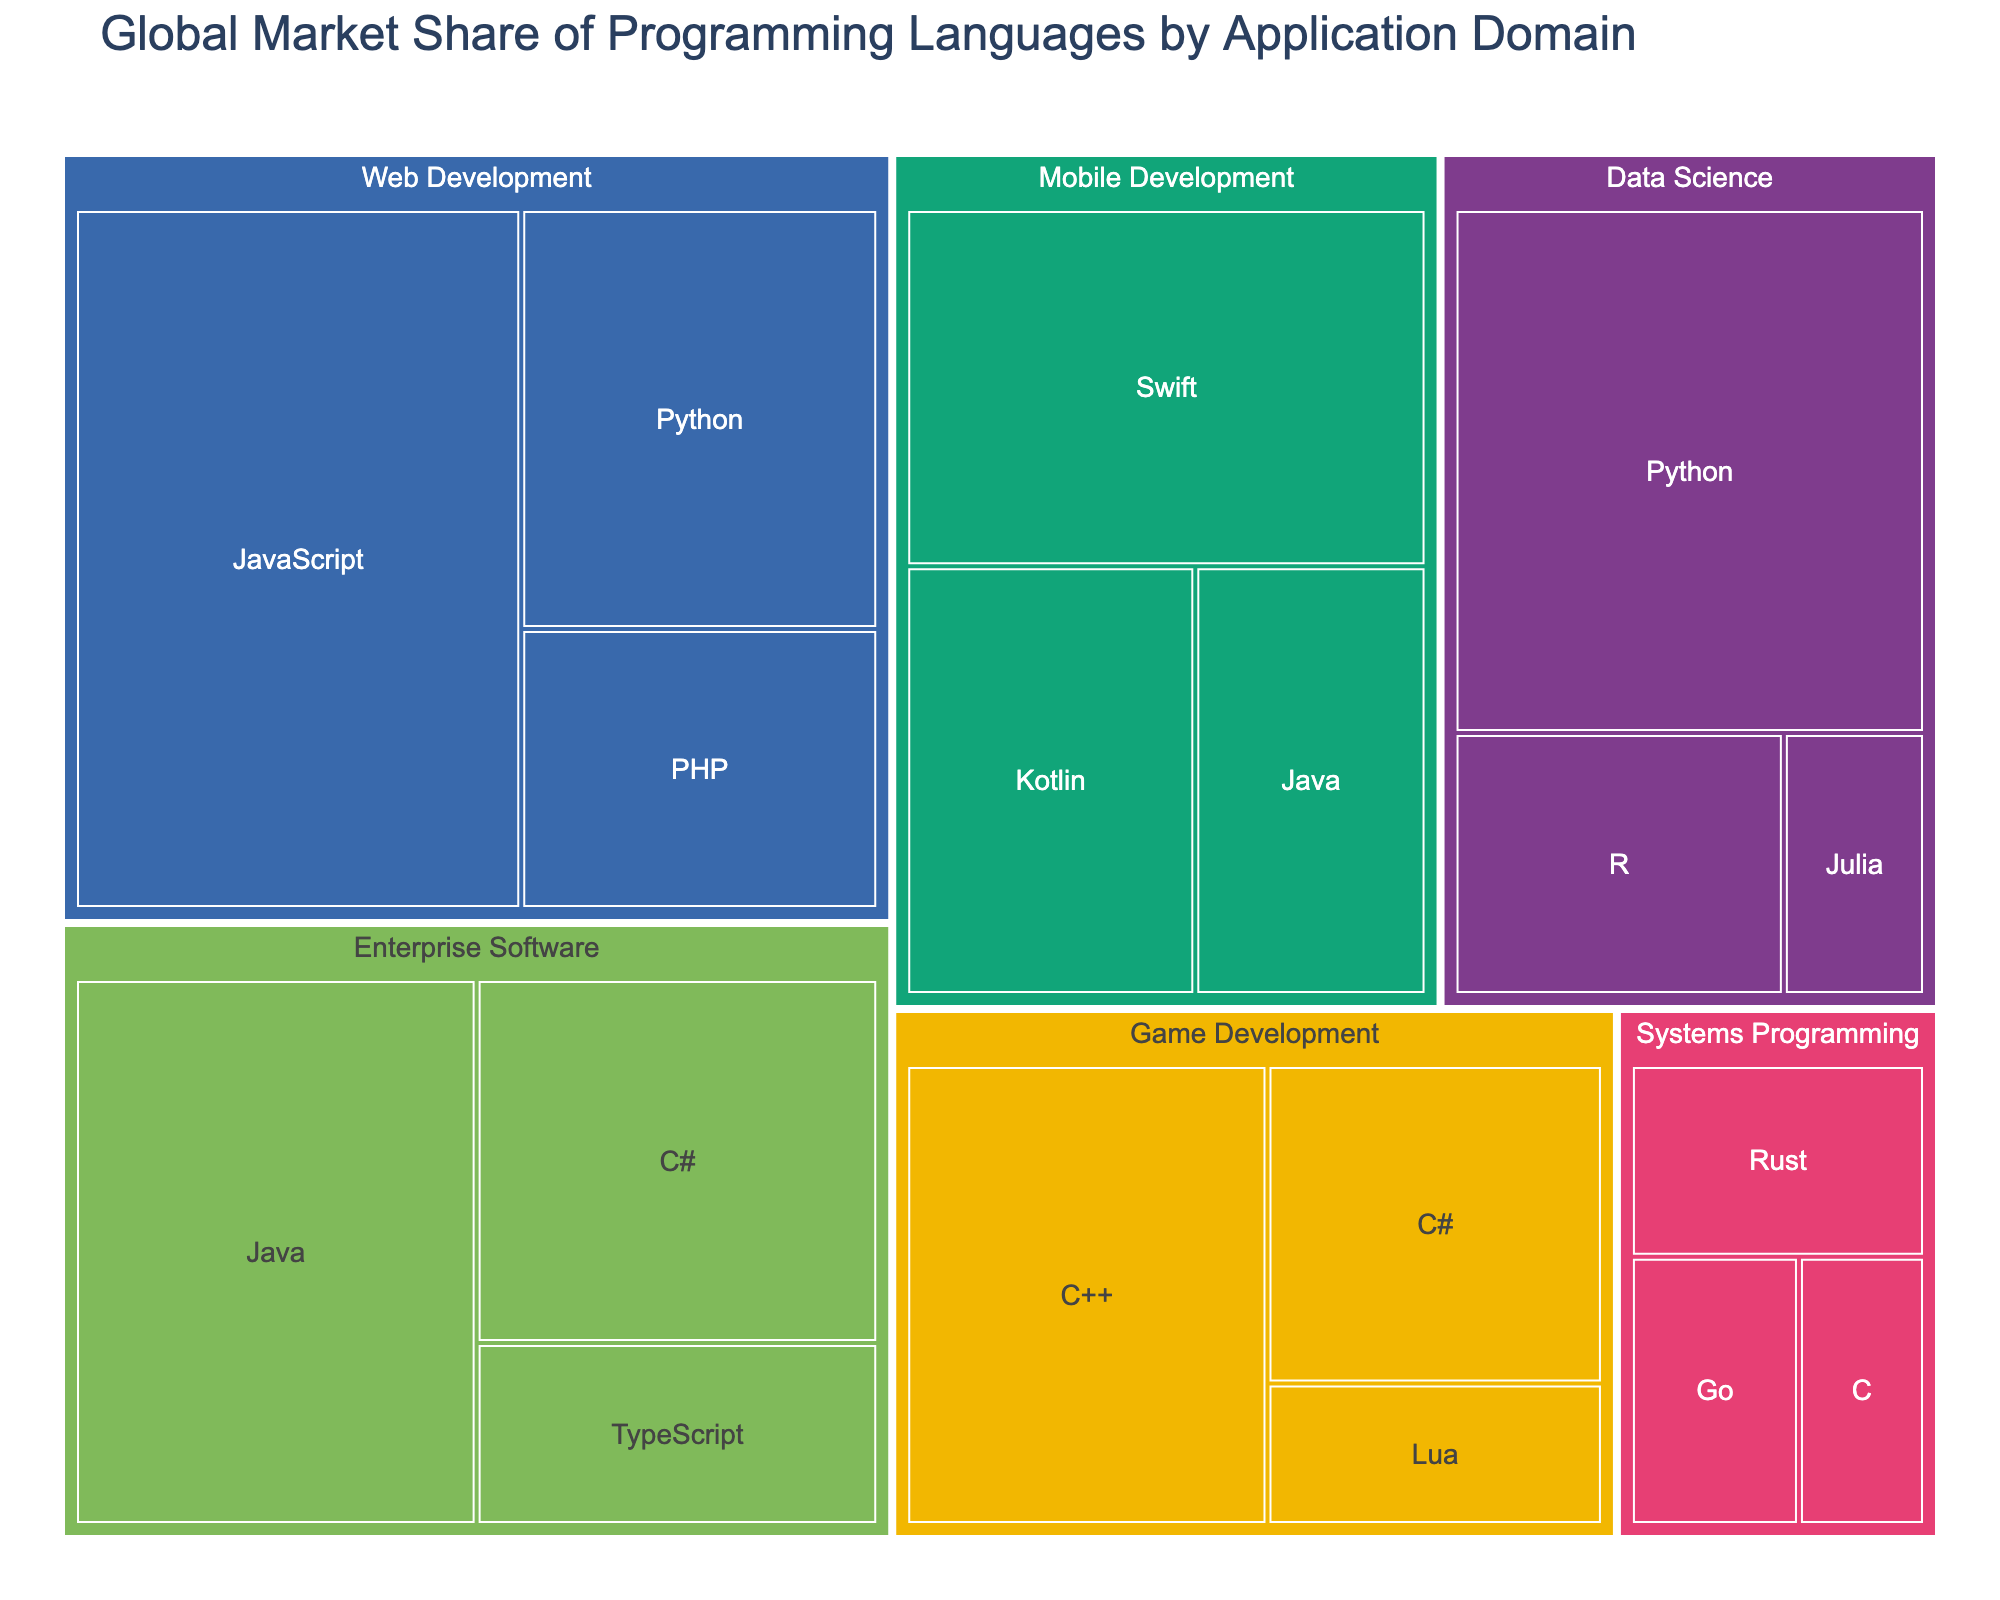1. What is the largest application domain in terms of global market share? Look at the treemap and identify which application domain has the largest area. Web Development has the largest area and thus the largest market share.
Answer: Web Development 2. Which programming language has the highest market share in data science? Find the Data Science application domain in the treemap and identify which programming language within it has the largest area. Python is the largest within Data Science.
Answer: Python 3. How does the market share of Java in enterprise software compare to the market share of Python in data science? Locate Java under Enterprise Software and Python under Data Science in the treemap, and compare their market share values. Java has 18% in Enterprise Software, while Python has 20% in Data Science.
Answer: Python has a higher market share 4. What is the combined market share of R and Julia in data science? Find the market shares for R (7%) and Julia (3%) under Data Science and add them together. 7% + 3% equals 10%.
Answer: 10% 5. Which programming language has the smallest market share in game development? Look at the Game Development section of the treemap and find the programming language with the smallest area. Lua has the smallest market share.
Answer: Lua 6. How many application domains feature Java as a programming language? Scan the treemap and count the different application domains where Java appears. Java appears in Mobile Development and Enterprise Software.
Answer: 2 7. What is the total market share of programming languages used in game development? Identify the market shares of the programming languages under Game Development: C++ (14%), C# (9%), and Lua (4%), then add them together. 14% + 9% + 4% = 27%.
Answer: 27% 8. Does Swift or Kotlin have a higher market share in mobile development? Look at the Mobile Development section and compare the market shares of Swift and Kotlin. Swift has 15% while Kotlin has 10%.
Answer: Swift 9. Which application domain has the least variety of programming languages? Count the number of different programming languages in each application domain. Systems Programming has Rust, Go, and C, which is fewer than other domains.
Answer: Systems Programming 10. What is the market share difference between JavaScript in web development and Java in mobile development? Locate JavaScript under Web Development (25%) and Java under Mobile Development (8%). Subtract 8% from 25%. 25% - 8% equals 17%.
Answer: 17% 